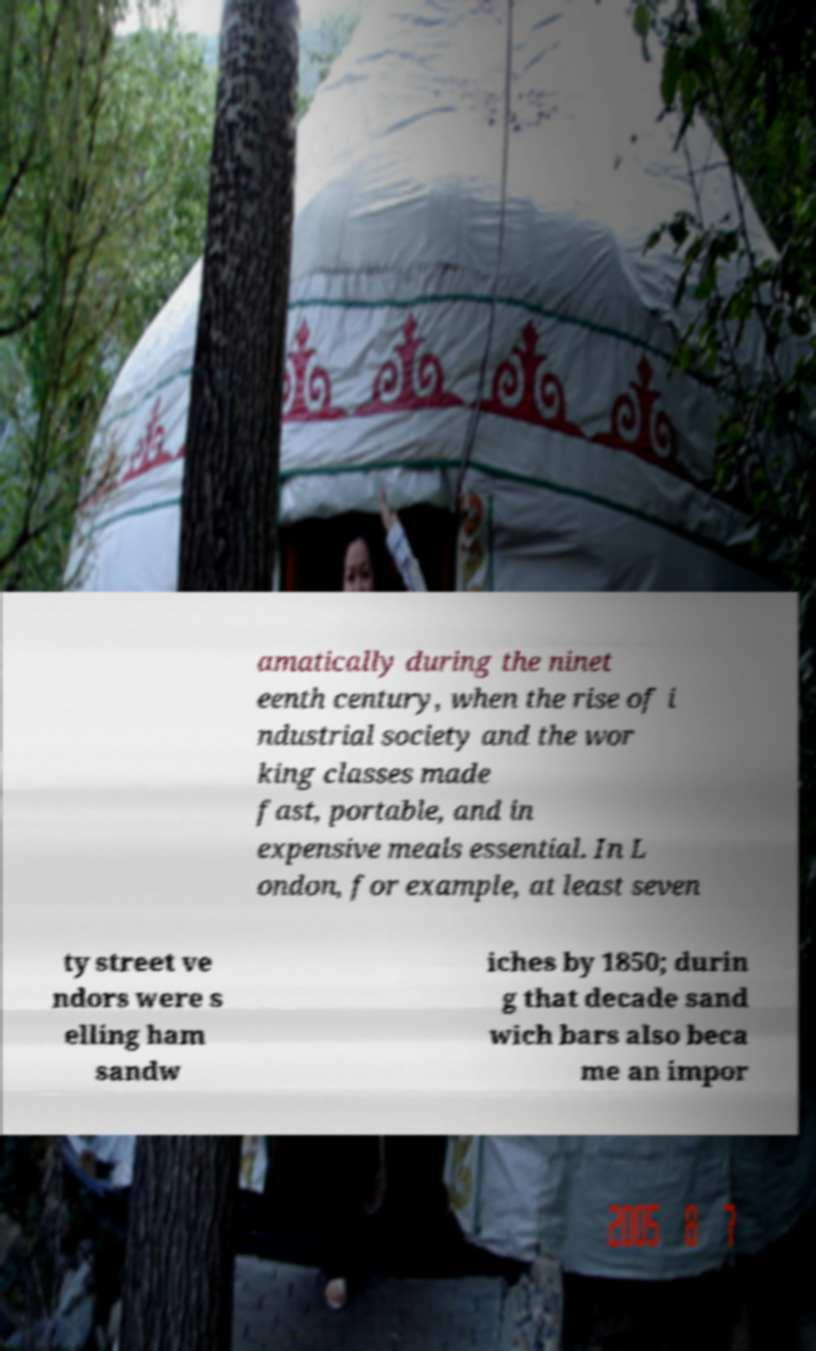Can you accurately transcribe the text from the provided image for me? amatically during the ninet eenth century, when the rise of i ndustrial society and the wor king classes made fast, portable, and in expensive meals essential. In L ondon, for example, at least seven ty street ve ndors were s elling ham sandw iches by 1850; durin g that decade sand wich bars also beca me an impor 